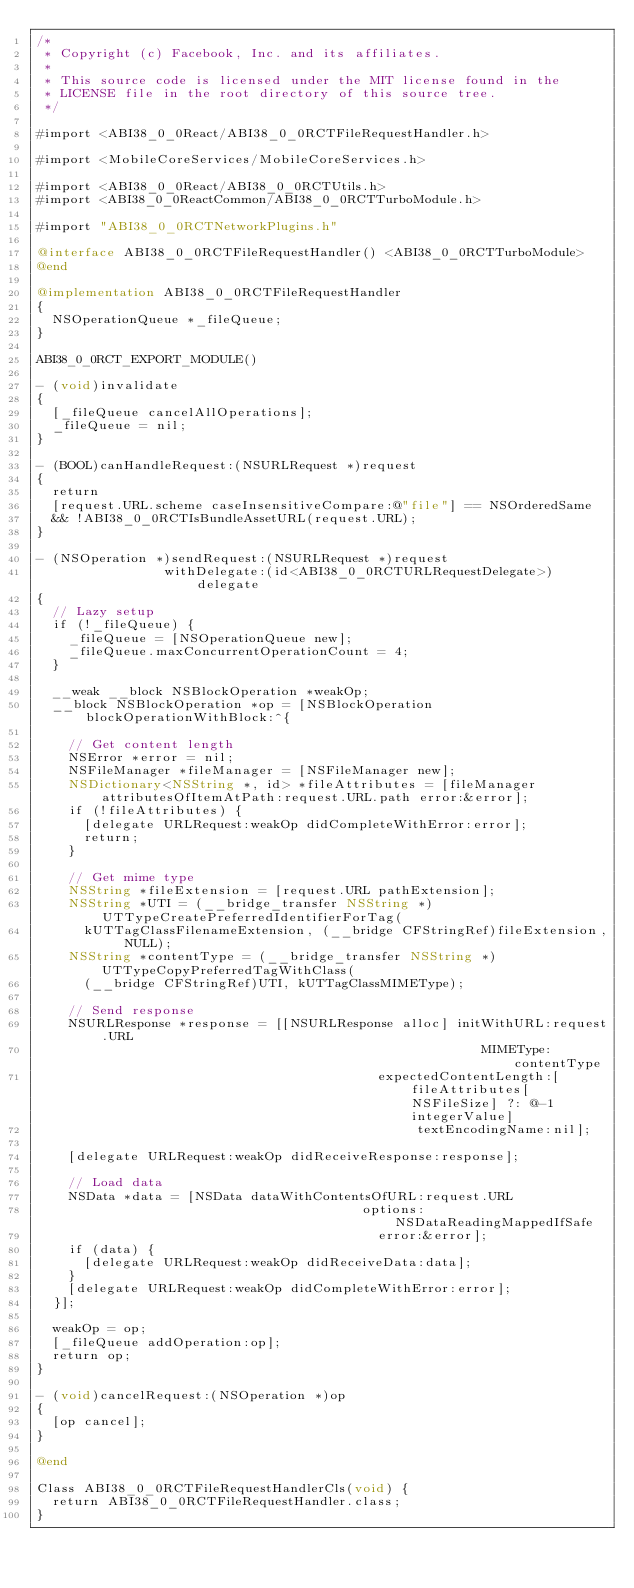<code> <loc_0><loc_0><loc_500><loc_500><_ObjectiveC_>/*
 * Copyright (c) Facebook, Inc. and its affiliates.
 *
 * This source code is licensed under the MIT license found in the
 * LICENSE file in the root directory of this source tree.
 */

#import <ABI38_0_0React/ABI38_0_0RCTFileRequestHandler.h>

#import <MobileCoreServices/MobileCoreServices.h>

#import <ABI38_0_0React/ABI38_0_0RCTUtils.h>
#import <ABI38_0_0ReactCommon/ABI38_0_0RCTTurboModule.h>

#import "ABI38_0_0RCTNetworkPlugins.h"

@interface ABI38_0_0RCTFileRequestHandler() <ABI38_0_0RCTTurboModule>
@end

@implementation ABI38_0_0RCTFileRequestHandler
{
  NSOperationQueue *_fileQueue;
}

ABI38_0_0RCT_EXPORT_MODULE()

- (void)invalidate
{
  [_fileQueue cancelAllOperations];
  _fileQueue = nil;
}

- (BOOL)canHandleRequest:(NSURLRequest *)request
{
  return
  [request.URL.scheme caseInsensitiveCompare:@"file"] == NSOrderedSame
  && !ABI38_0_0RCTIsBundleAssetURL(request.URL);
}

- (NSOperation *)sendRequest:(NSURLRequest *)request
                withDelegate:(id<ABI38_0_0RCTURLRequestDelegate>)delegate
{
  // Lazy setup
  if (!_fileQueue) {
    _fileQueue = [NSOperationQueue new];
    _fileQueue.maxConcurrentOperationCount = 4;
  }

  __weak __block NSBlockOperation *weakOp;
  __block NSBlockOperation *op = [NSBlockOperation blockOperationWithBlock:^{

    // Get content length
    NSError *error = nil;
    NSFileManager *fileManager = [NSFileManager new];
    NSDictionary<NSString *, id> *fileAttributes = [fileManager attributesOfItemAtPath:request.URL.path error:&error];
    if (!fileAttributes) {
      [delegate URLRequest:weakOp didCompleteWithError:error];
      return;
    }

    // Get mime type
    NSString *fileExtension = [request.URL pathExtension];
    NSString *UTI = (__bridge_transfer NSString *)UTTypeCreatePreferredIdentifierForTag(
      kUTTagClassFilenameExtension, (__bridge CFStringRef)fileExtension, NULL);
    NSString *contentType = (__bridge_transfer NSString *)UTTypeCopyPreferredTagWithClass(
      (__bridge CFStringRef)UTI, kUTTagClassMIMEType);

    // Send response
    NSURLResponse *response = [[NSURLResponse alloc] initWithURL:request.URL
                                                        MIMEType:contentType
                                           expectedContentLength:[fileAttributes[NSFileSize] ?: @-1 integerValue]
                                                textEncodingName:nil];

    [delegate URLRequest:weakOp didReceiveResponse:response];

    // Load data
    NSData *data = [NSData dataWithContentsOfURL:request.URL
                                         options:NSDataReadingMappedIfSafe
                                           error:&error];
    if (data) {
      [delegate URLRequest:weakOp didReceiveData:data];
    }
    [delegate URLRequest:weakOp didCompleteWithError:error];
  }];

  weakOp = op;
  [_fileQueue addOperation:op];
  return op;
}

- (void)cancelRequest:(NSOperation *)op
{
  [op cancel];
}

@end

Class ABI38_0_0RCTFileRequestHandlerCls(void) {
  return ABI38_0_0RCTFileRequestHandler.class;
}
</code> 